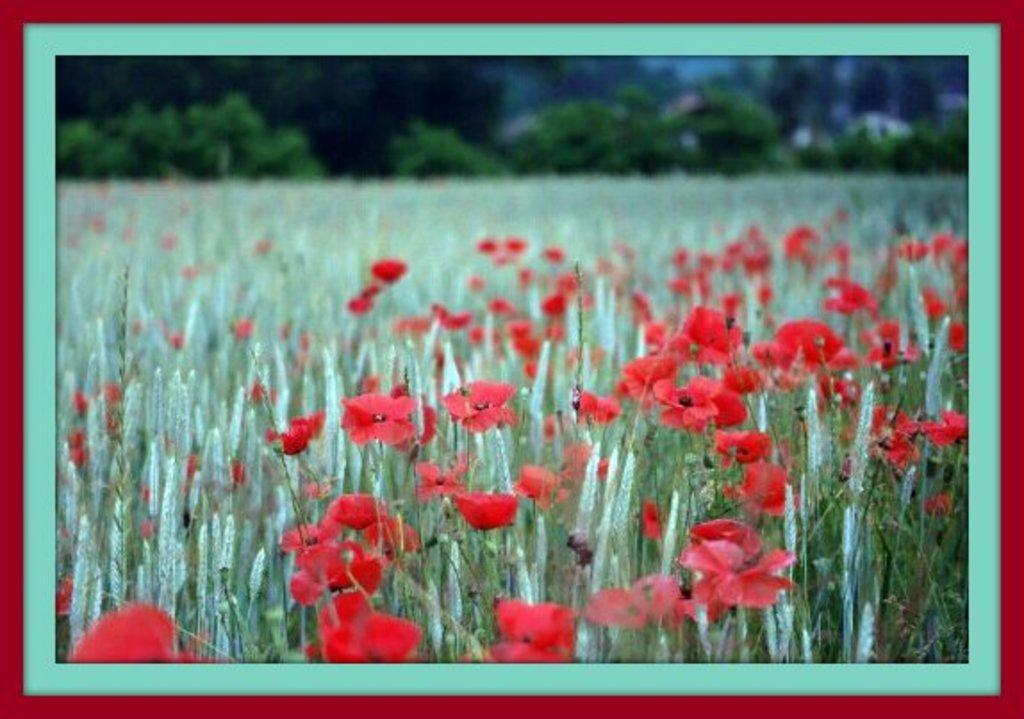What object is the main focus of the image? There is a photo frame in the image. What is depicted in the photo frame? The photo frame contains a photo of flower plants. What can be seen in the background of the image? There are trees visible in the background of the image. What colors are used for the border of the photo frame? The photo frame has a blue and maroon border. What type of whip can be seen hanging from the tree in the image? There is no whip present in the image; it features a photo frame with a photo of flower plants and trees in the background. What kind of nut is being used to hold the photo frame in place? There is no nut used to hold the photo frame in place; it is simply resting on a surface. 